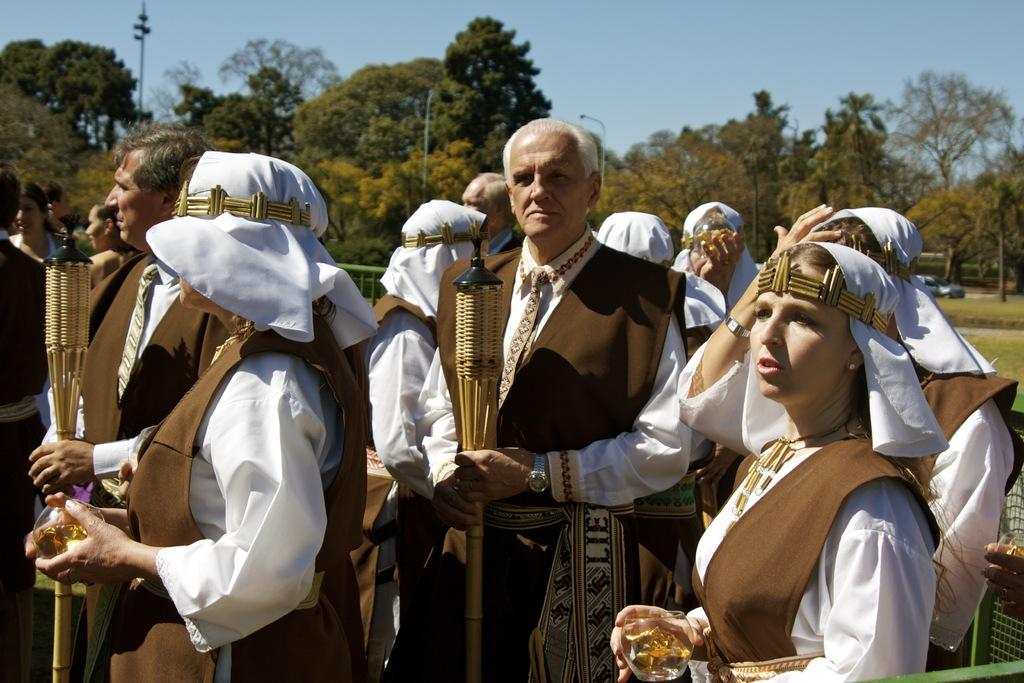What are the people in the image doing? The people in the image are standing and holding objects. Can you describe the mesh visible in the image? Yes, there is a mesh visible in the image. What can be seen in the background of the image? In the background of the image, there are trees, a car, poles, and the sky. What type of wound can be seen on the person's toe in the image? There is no person with a wound on their toe in the image. What kind of plastic material is used to make the objects the people are holding in the image? The provided facts do not mention the material of the objects the people are holding, so we cannot determine if they are made of plastic. 